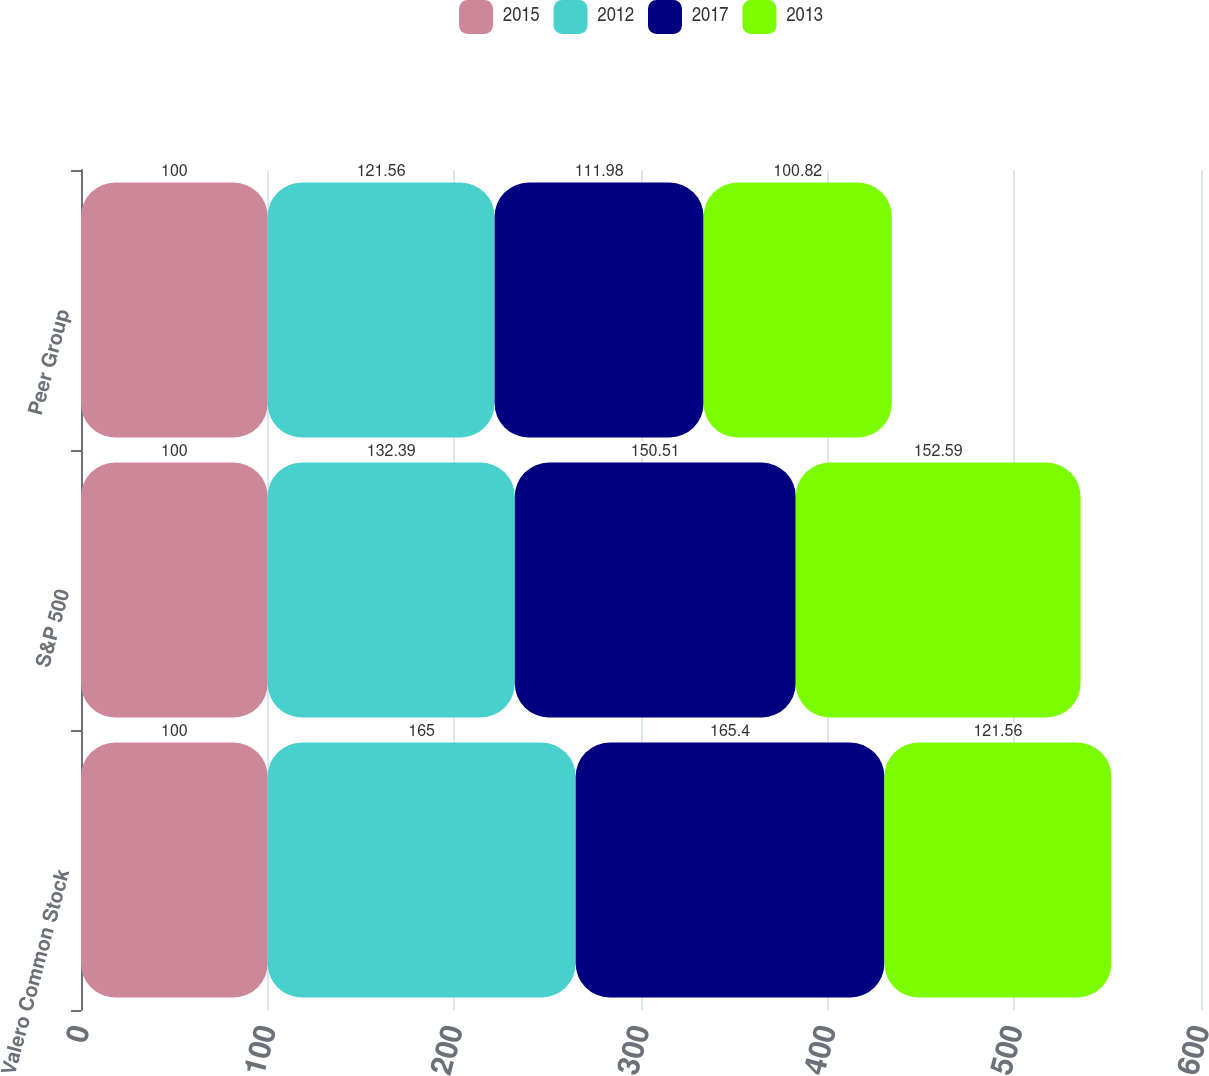Convert chart. <chart><loc_0><loc_0><loc_500><loc_500><stacked_bar_chart><ecel><fcel>Valero Common Stock<fcel>S&P 500<fcel>Peer Group<nl><fcel>2015<fcel>100<fcel>100<fcel>100<nl><fcel>2012<fcel>165<fcel>132.39<fcel>121.56<nl><fcel>2017<fcel>165.4<fcel>150.51<fcel>111.98<nl><fcel>2013<fcel>121.56<fcel>152.59<fcel>100.82<nl></chart> 